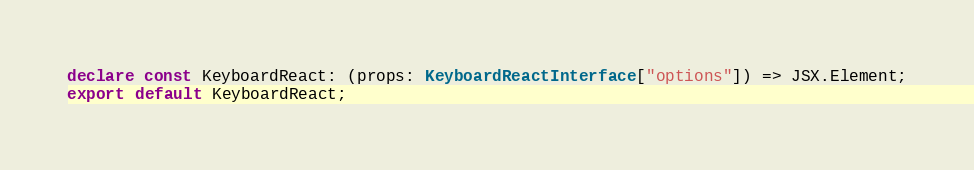<code> <loc_0><loc_0><loc_500><loc_500><_TypeScript_>declare const KeyboardReact: (props: KeyboardReactInterface["options"]) => JSX.Element;
export default KeyboardReact;
</code> 